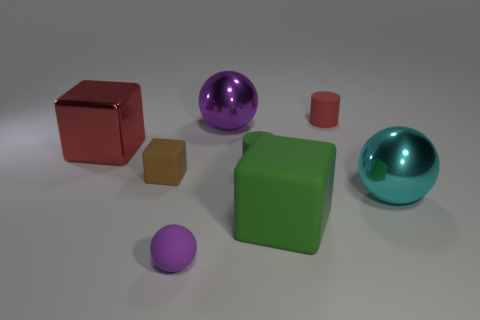What material is the red thing that is the same size as the cyan shiny thing?
Provide a short and direct response. Metal. There is a red thing on the left side of the red rubber cylinder; is it the same size as the red rubber cylinder?
Offer a terse response. No. There is a large shiny object to the left of the big purple metallic thing; is its shape the same as the purple metal object?
Your response must be concise. No. How many things are either small brown matte things or rubber blocks that are on the left side of the green matte block?
Your answer should be very brief. 1. Is the number of green cylinders less than the number of large yellow metal cylinders?
Keep it short and to the point. No. Is the number of cyan things greater than the number of big metallic balls?
Give a very brief answer. No. How many other things are made of the same material as the small green thing?
Offer a very short reply. 4. There is a big sphere in front of the sphere behind the red cube; how many cyan balls are behind it?
Provide a short and direct response. 0. How many matte things are blue things or small spheres?
Give a very brief answer. 1. What is the size of the shiny ball right of the big green rubber thing to the right of the large red block?
Offer a terse response. Large. 